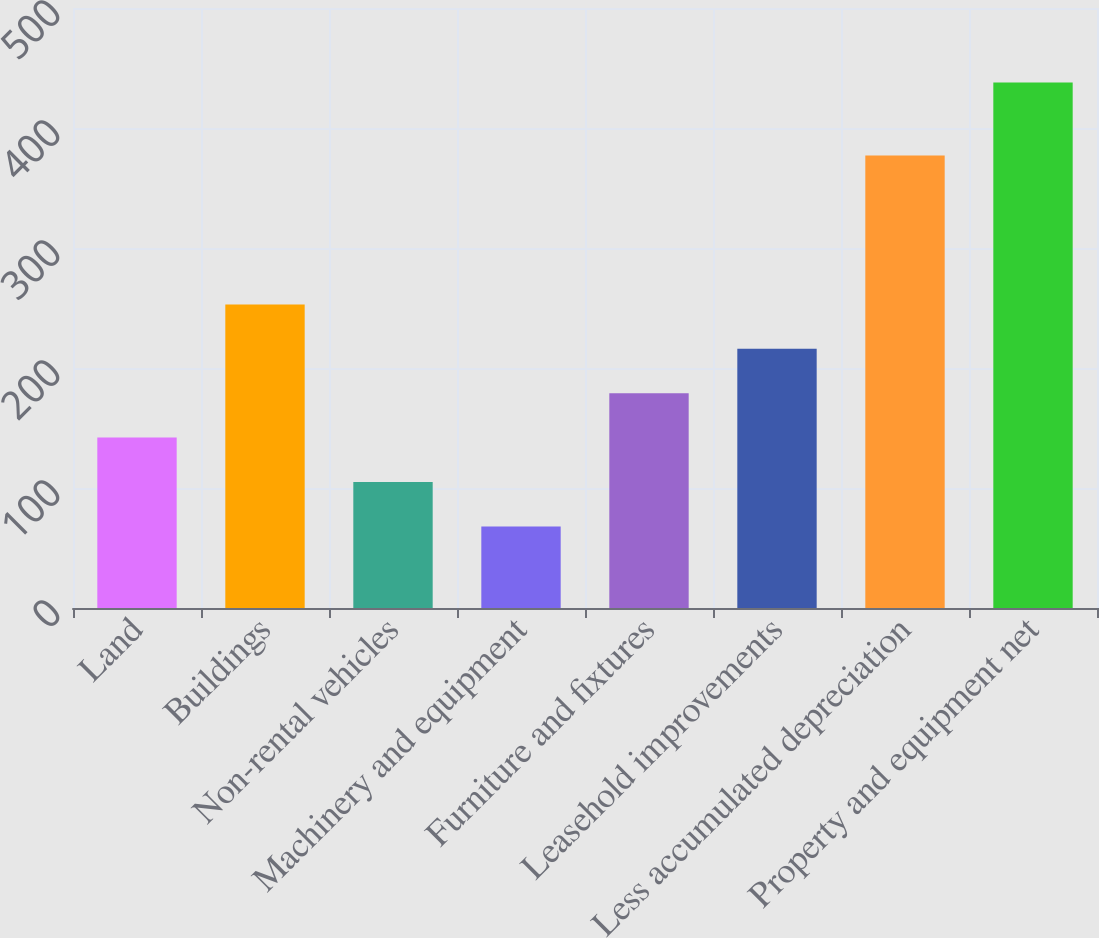Convert chart to OTSL. <chart><loc_0><loc_0><loc_500><loc_500><bar_chart><fcel>Land<fcel>Buildings<fcel>Non-rental vehicles<fcel>Machinery and equipment<fcel>Furniture and fixtures<fcel>Leasehold improvements<fcel>Less accumulated depreciation<fcel>Property and equipment net<nl><fcel>142<fcel>253<fcel>105<fcel>68<fcel>179<fcel>216<fcel>377<fcel>438<nl></chart> 